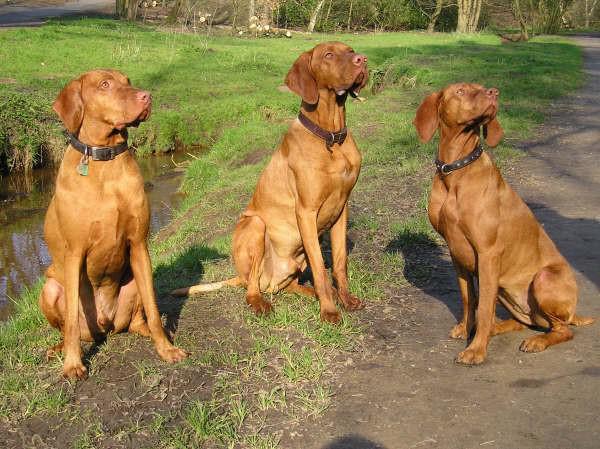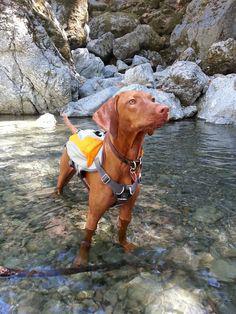The first image is the image on the left, the second image is the image on the right. Evaluate the accuracy of this statement regarding the images: "There are three dogs sitting.". Is it true? Answer yes or no. Yes. The first image is the image on the left, the second image is the image on the right. Assess this claim about the two images: "One dog is wearing an item on it's back and the rest are only wearing collars.". Correct or not? Answer yes or no. Yes. 